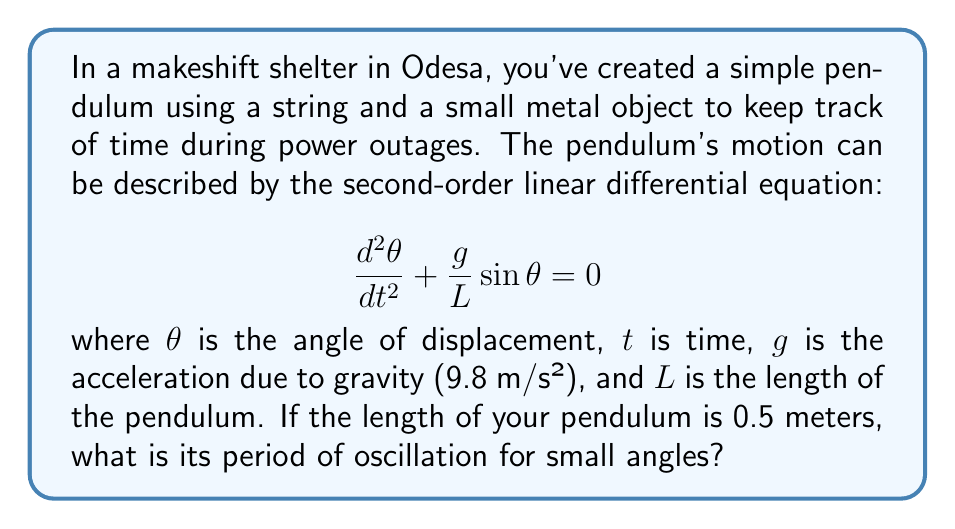Give your solution to this math problem. To solve this problem, we'll follow these steps:

1) For small angles, $\sin\theta \approx \theta$, so our equation becomes:

   $$\frac{d^2\theta}{dt^2} + \frac{g}{L}\theta = 0$$

2) This is in the form of a simple harmonic oscillator, where the angular frequency $\omega$ is given by:

   $$\omega = \sqrt{\frac{g}{L}}$$

3) The period $T$ of a simple harmonic oscillator is related to the angular frequency by:

   $$T = \frac{2\pi}{\omega}$$

4) Substituting the expression for $\omega$:

   $$T = 2\pi\sqrt{\frac{L}{g}}$$

5) Now, let's plug in our values:
   $L = 0.5$ m
   $g = 9.8$ m/s²

   $$T = 2\pi\sqrt{\frac{0.5}{9.8}}$$

6) Calculating:

   $$T = 2\pi\sqrt{0.0510} \approx 1.42 \text{ seconds}$$

Therefore, the period of oscillation for your makeshift pendulum is approximately 1.42 seconds.
Answer: 1.42 seconds 